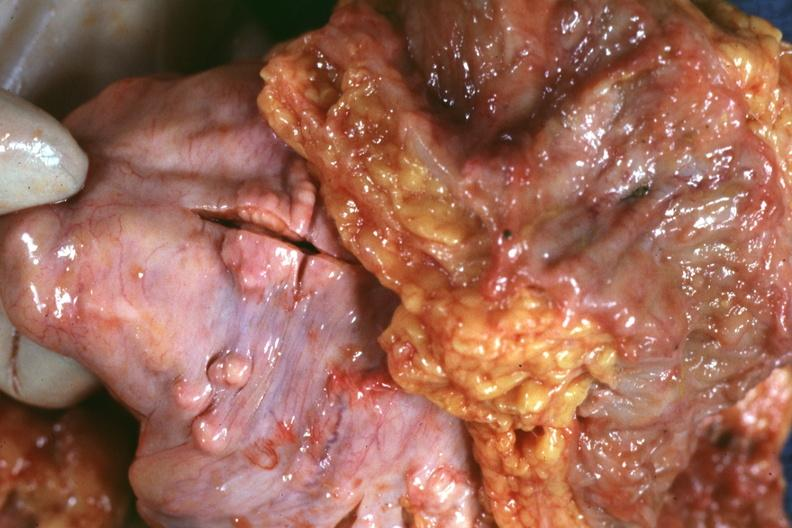what is present?
Answer the question using a single word or phrase. Abdomen 